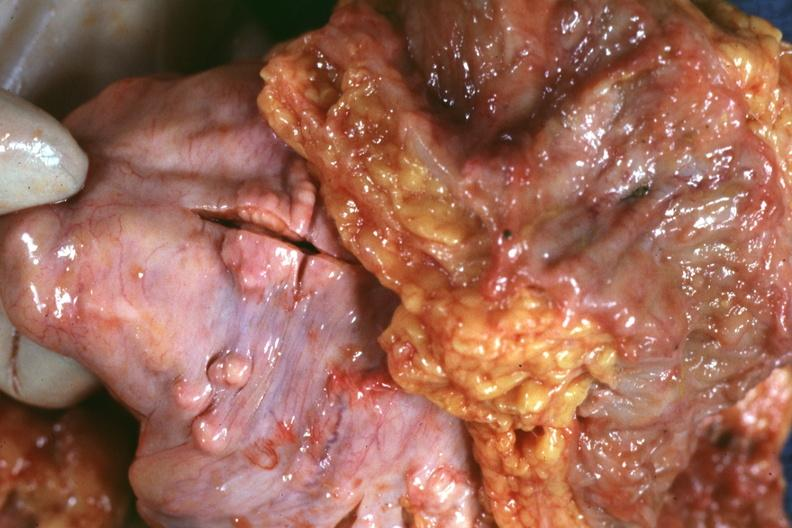what is present?
Answer the question using a single word or phrase. Abdomen 